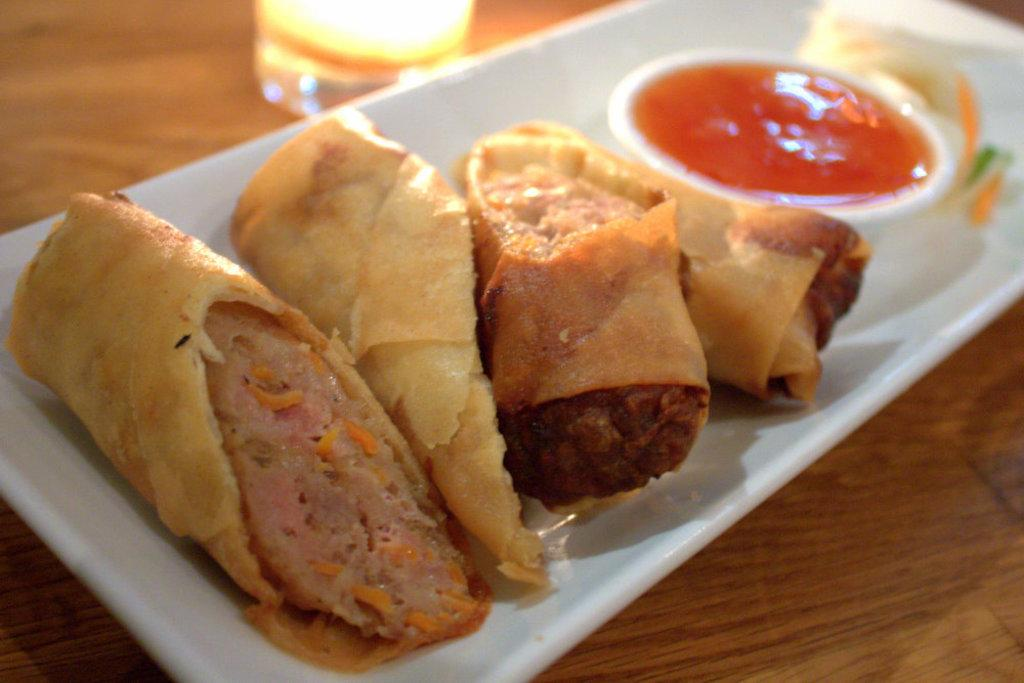What is on the plate in the image? There are food items on a plate in the image. What accompanies the food items on the plate? There is a sauce on the plate. Where are the plate and glass located in the image? The plate and a glass are on a table. How many years have passed since the visitor last saw the food items in the image? There is no visitor or indication of time in the image, so it is not possible to determine how many years have passed. 